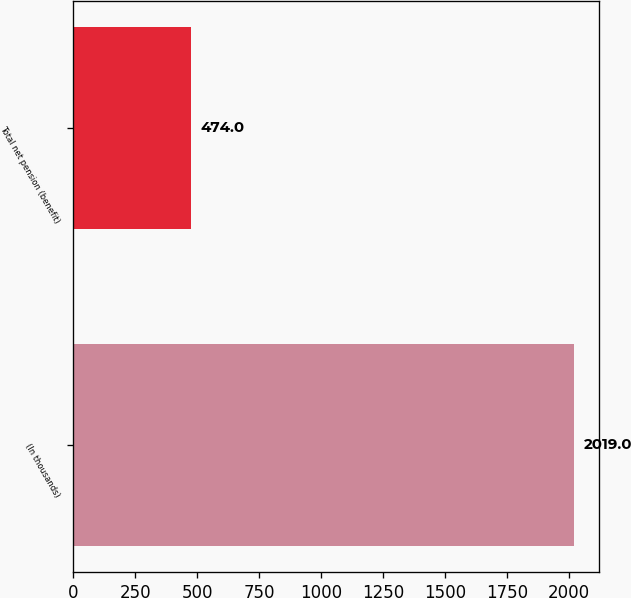Convert chart to OTSL. <chart><loc_0><loc_0><loc_500><loc_500><bar_chart><fcel>(In thousands)<fcel>Total net pension (benefit)<nl><fcel>2019<fcel>474<nl></chart> 